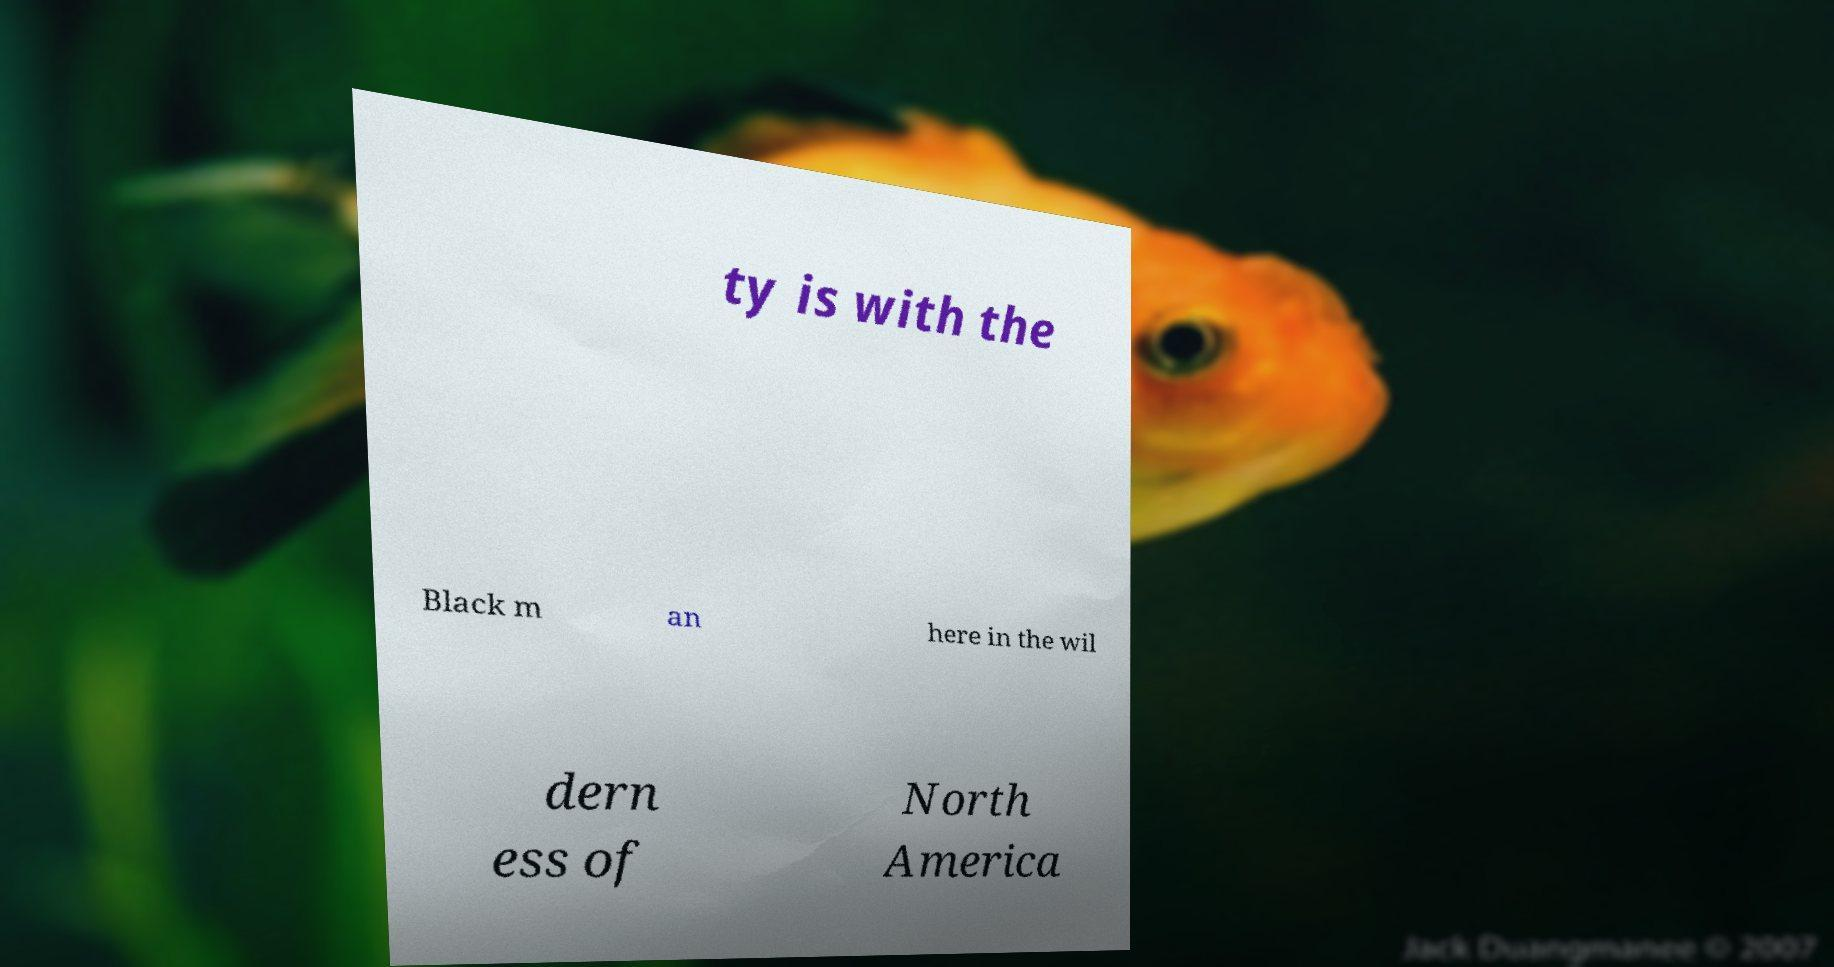Please read and relay the text visible in this image. What does it say? ty is with the Black m an here in the wil dern ess of North America 